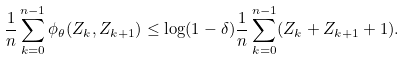<formula> <loc_0><loc_0><loc_500><loc_500>\frac { 1 } { n } \sum _ { k = 0 } ^ { n - 1 } \phi _ { \theta } ( Z _ { k } , Z _ { k + 1 } ) \leq \log ( 1 - \delta ) \frac { 1 } { n } \sum _ { k = 0 } ^ { n - 1 } ( Z _ { k } + Z _ { k + 1 } + 1 ) .</formula> 